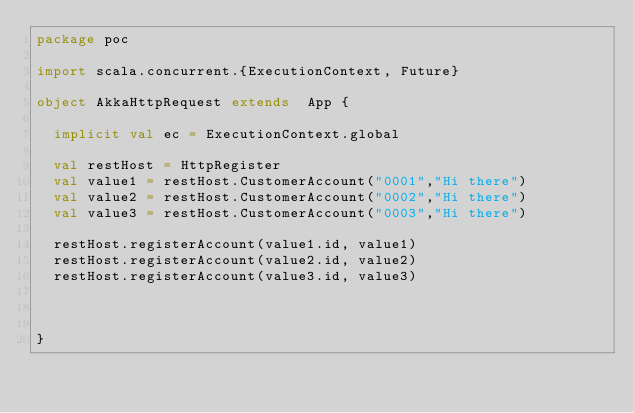Convert code to text. <code><loc_0><loc_0><loc_500><loc_500><_Scala_>package poc

import scala.concurrent.{ExecutionContext, Future}

object AkkaHttpRequest extends  App {

  implicit val ec = ExecutionContext.global

  val restHost = HttpRegister
  val value1 = restHost.CustomerAccount("0001","Hi there")
  val value2 = restHost.CustomerAccount("0002","Hi there")
  val value3 = restHost.CustomerAccount("0003","Hi there")

  restHost.registerAccount(value1.id, value1)
  restHost.registerAccount(value2.id, value2)
  restHost.registerAccount(value3.id, value3)



}
</code> 